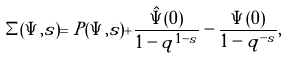Convert formula to latex. <formula><loc_0><loc_0><loc_500><loc_500>\Sigma ( \Psi , s ) = P ( \Psi , s ) + \frac { \hat { \Psi } ( 0 ) } { 1 - q ^ { 1 - s } } - \frac { \Psi ( 0 ) } { 1 - q ^ { - s } } ,</formula> 